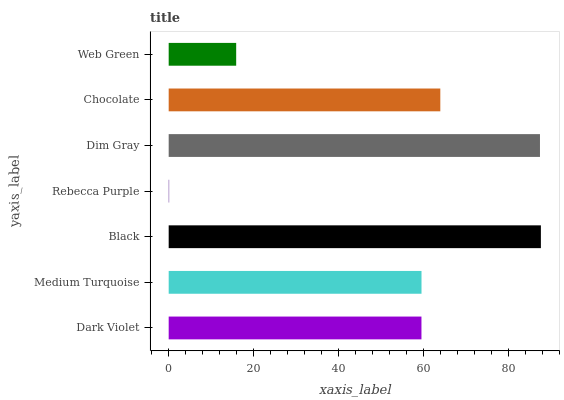Is Rebecca Purple the minimum?
Answer yes or no. Yes. Is Black the maximum?
Answer yes or no. Yes. Is Medium Turquoise the minimum?
Answer yes or no. No. Is Medium Turquoise the maximum?
Answer yes or no. No. Is Medium Turquoise greater than Dark Violet?
Answer yes or no. Yes. Is Dark Violet less than Medium Turquoise?
Answer yes or no. Yes. Is Dark Violet greater than Medium Turquoise?
Answer yes or no. No. Is Medium Turquoise less than Dark Violet?
Answer yes or no. No. Is Medium Turquoise the high median?
Answer yes or no. Yes. Is Medium Turquoise the low median?
Answer yes or no. Yes. Is Rebecca Purple the high median?
Answer yes or no. No. Is Dim Gray the low median?
Answer yes or no. No. 